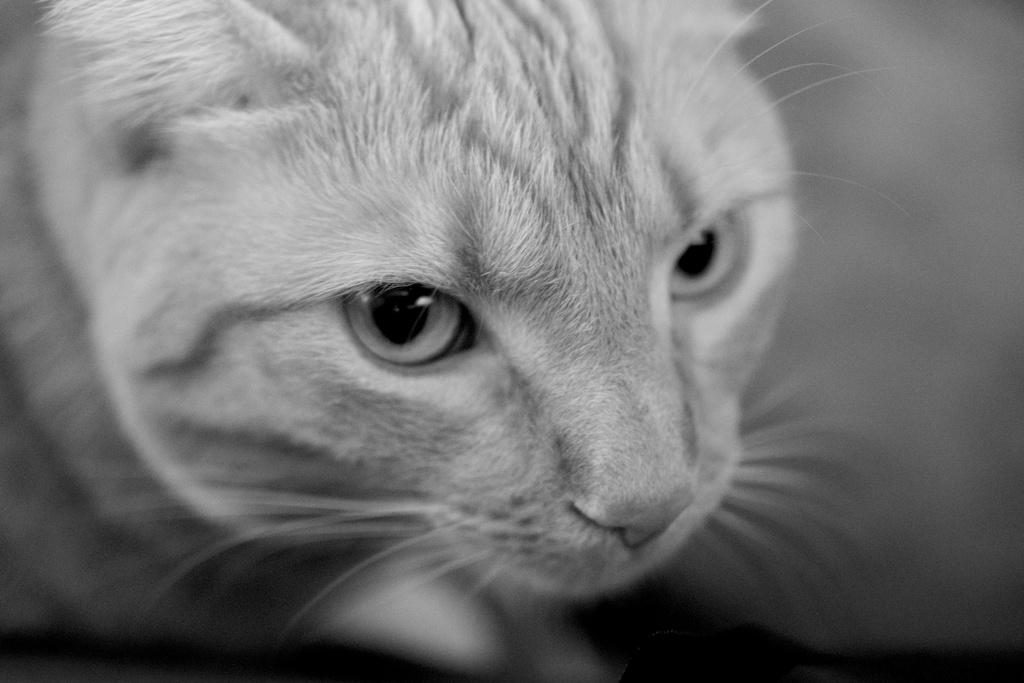What is the color scheme of the image? The image is black and white. What type of animal can be seen in the image? There is a cat in the image. Is there a beggar holding a can in the image? No, there is no beggar or can present in the image; it only features a cat. Can you see a wrench in the image? No, there is no wrench present in the image; it only features a cat. 